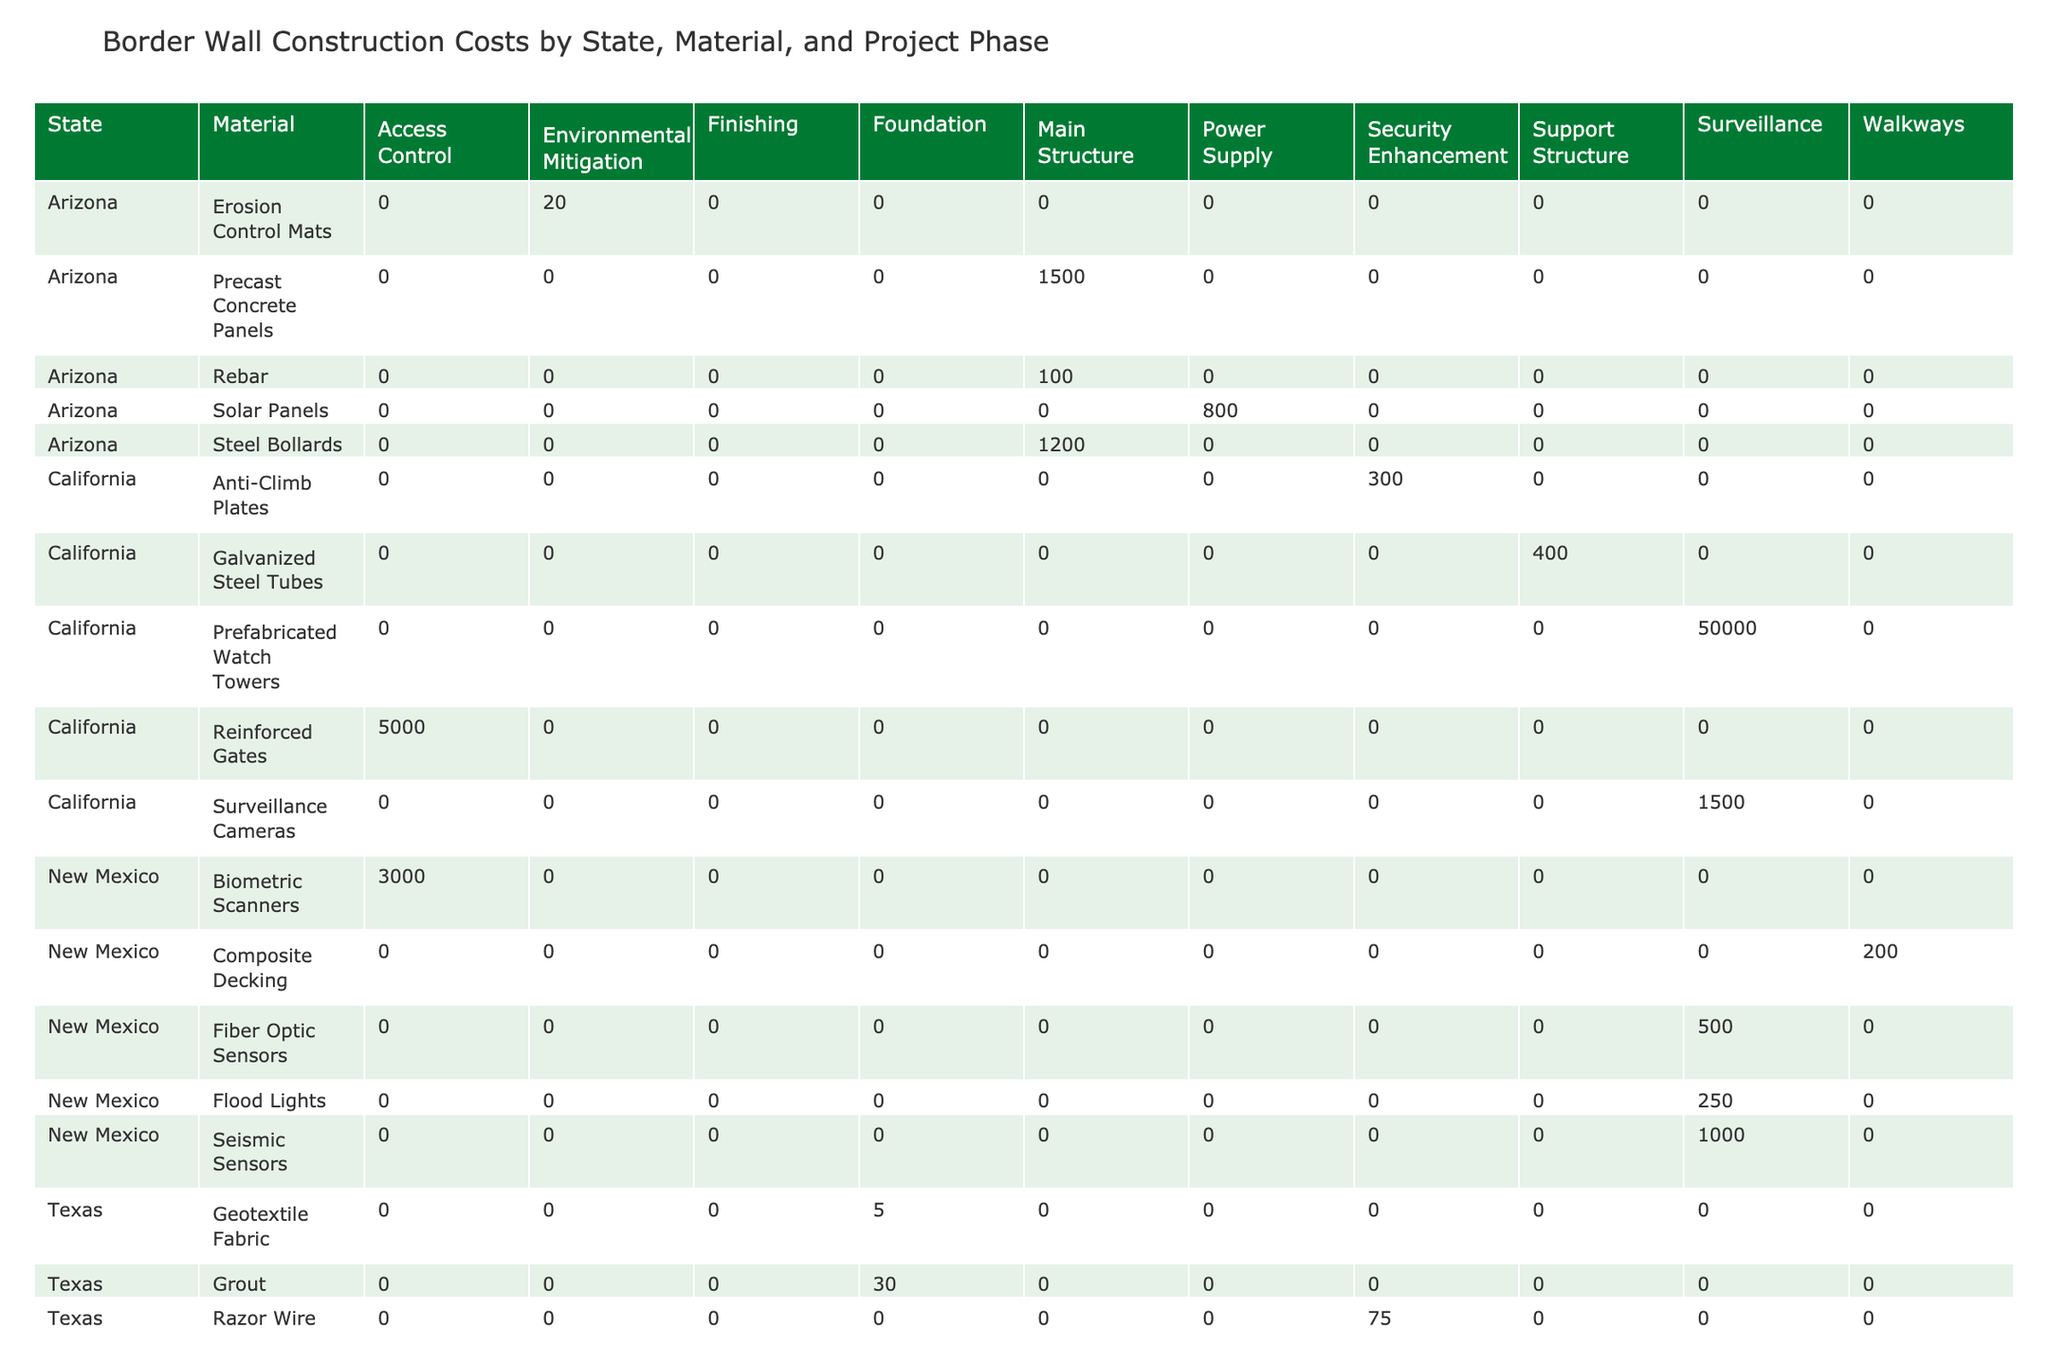What is the cost per unit of Steel Bollards in Arizona? According to the table, the 'Cost_per_Unit' for Steel Bollards under 'Main Structure' in Arizona is clearly stated as 1200.
Answer: 1200 Which material has the highest cost per unit in California? In California, the materials listed are Anti-Climb Plates (300), Galvanized Steel Tubes (400), Reinforced Gates (5000), and Surveillance Cameras (1500). The highest among these is Reinforced Gates at 5000.
Answer: 5000 What are the total costs of units used for Reinforced Concrete in Texas? The cost per unit for Reinforced Concrete in Texas is 850, and the units used are 12500. Therefore, total cost equals 850 * 12500 = 10625000.
Answer: 10625000 Is the Environmental Impact Score for Razor Wire in Texas higher than that for Solar Panels in Arizona? The environmental impact score for Razor Wire in Texas is 8, while the score for Solar Panels in Arizona is 1. Since 8 is greater than 1, the answer is yes.
Answer: Yes How much total cost is associated with the materials used for the Foundation phase across all states? The materials used for the Foundation phase are Reinforced Concrete and Grout in Texas (850 * 12500 + 30 * 50000 = 10625000 + 1500000 = 12125000). The total cost for this phase is 12125000.
Answer: 12125000 What is the average cost per unit of materials used in Arizona? Arizona has Steel Bollards (1200), Precast Concrete Panels (1500), Rebar (100), and Erosion Control Mats (20). The sum is (1200 + 1500 + 100 + 20) = 2820. There are 4 materials, so the average cost per unit is 2820 / 4 = 705.
Answer: 705 Is there any North Dakota data related to this table on material usage? No data is provided for North Dakota in the table, with all entries pertaining to specified states: Texas, Arizona, California, and New Mexico.
Answer: No Which state has the highest number of units used for a single type of material? In Texas, the Grout material has the highest units used, totaling 50000. This is higher than any other material used in other states.
Answer: Texas How many materials listed have an Environmental Impact Score of 2 or lower, and what are they? The materials with an environmental impact score of 2 or lower are Fiber Optic Sensors (2), Solar Panels (1), and Biometric Scanners (1). There are 3 such materials listed.
Answer: 3 